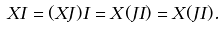<formula> <loc_0><loc_0><loc_500><loc_500>X I = ( X J ) I = X ( J I ) = X ( J I ) .</formula> 